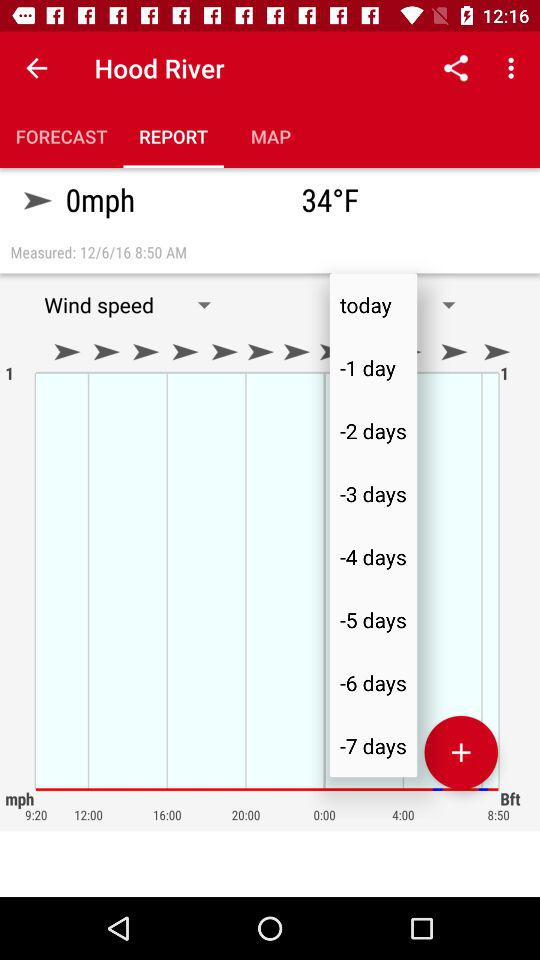Which option is selected in the "Hood River"? The selected option is "REPORT". 